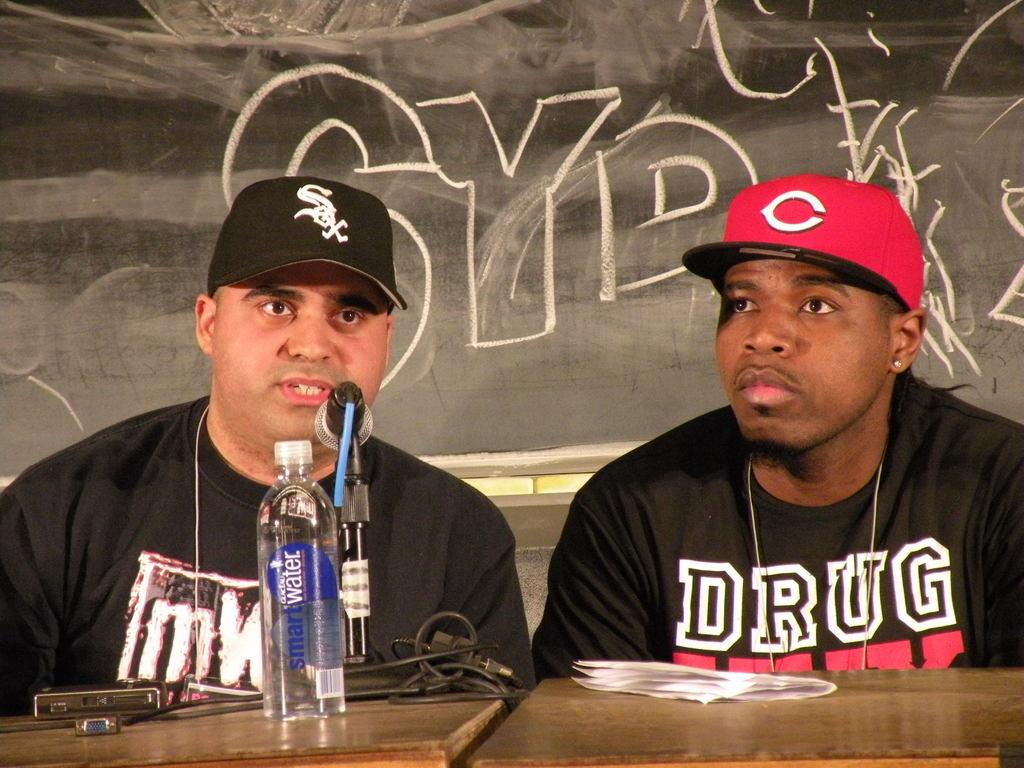Provide a one-sentence caption for the provided image. One of the guys speaking has a Smart Water bottle in front of him. 